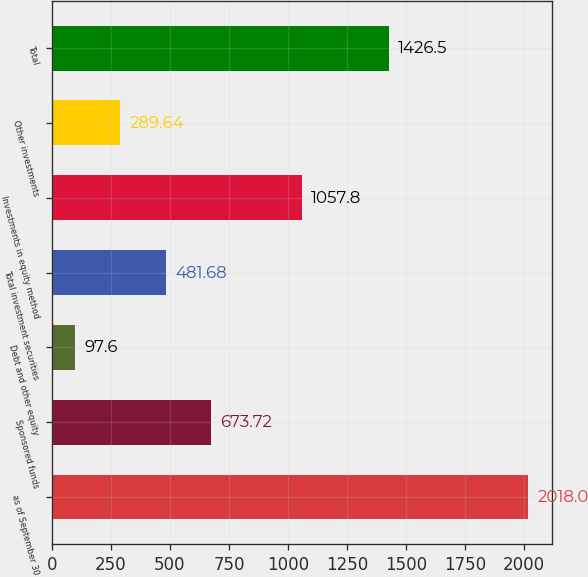Convert chart. <chart><loc_0><loc_0><loc_500><loc_500><bar_chart><fcel>as of September 30<fcel>Sponsored funds<fcel>Debt and other equity<fcel>Total investment securities<fcel>Investments in equity method<fcel>Other investments<fcel>Total<nl><fcel>2018<fcel>673.72<fcel>97.6<fcel>481.68<fcel>1057.8<fcel>289.64<fcel>1426.5<nl></chart> 